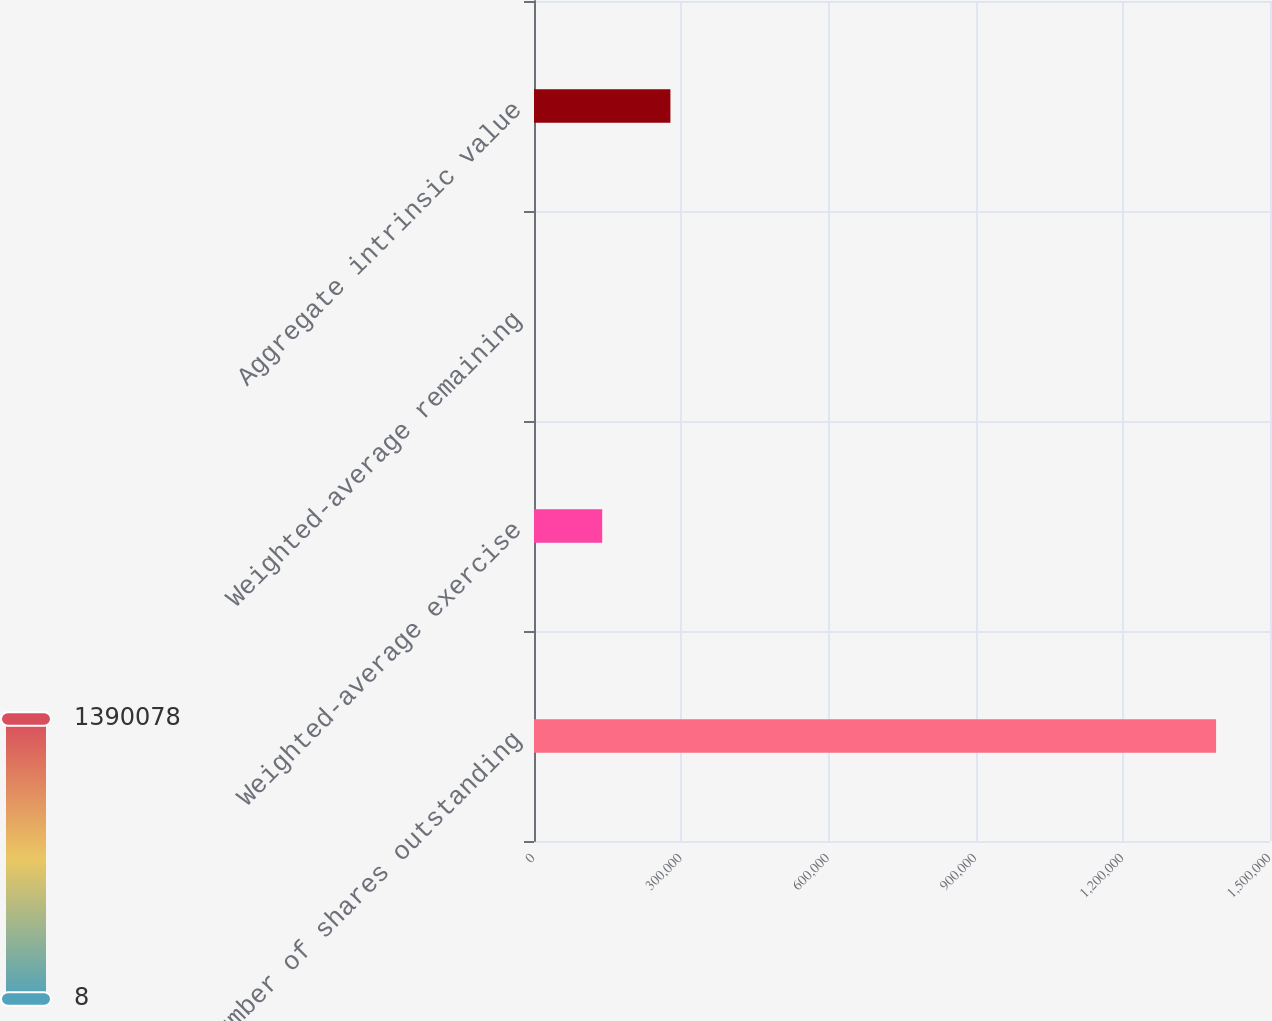<chart> <loc_0><loc_0><loc_500><loc_500><bar_chart><fcel>Number of shares outstanding<fcel>Weighted-average exercise<fcel>Weighted-average remaining<fcel>Aggregate intrinsic value<nl><fcel>1.39008e+06<fcel>139015<fcel>7.51<fcel>278022<nl></chart> 